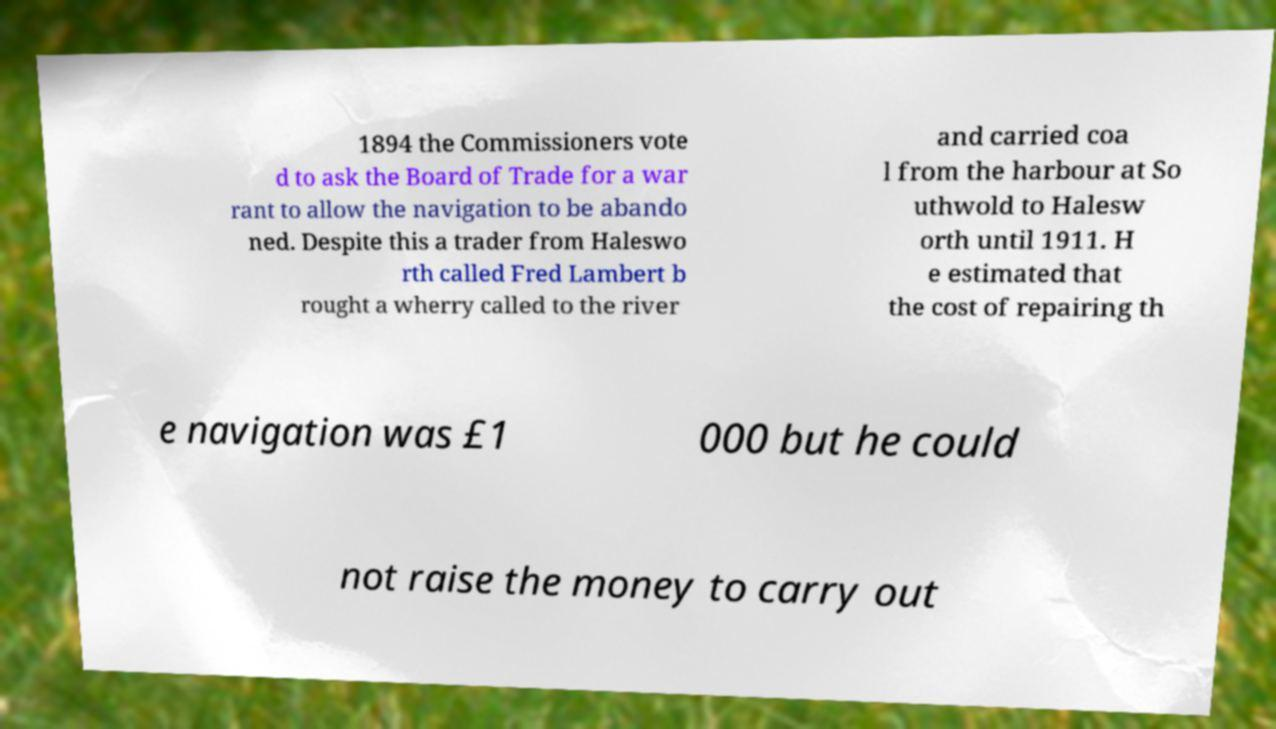I need the written content from this picture converted into text. Can you do that? 1894 the Commissioners vote d to ask the Board of Trade for a war rant to allow the navigation to be abando ned. Despite this a trader from Haleswo rth called Fred Lambert b rought a wherry called to the river and carried coa l from the harbour at So uthwold to Halesw orth until 1911. H e estimated that the cost of repairing th e navigation was £1 000 but he could not raise the money to carry out 